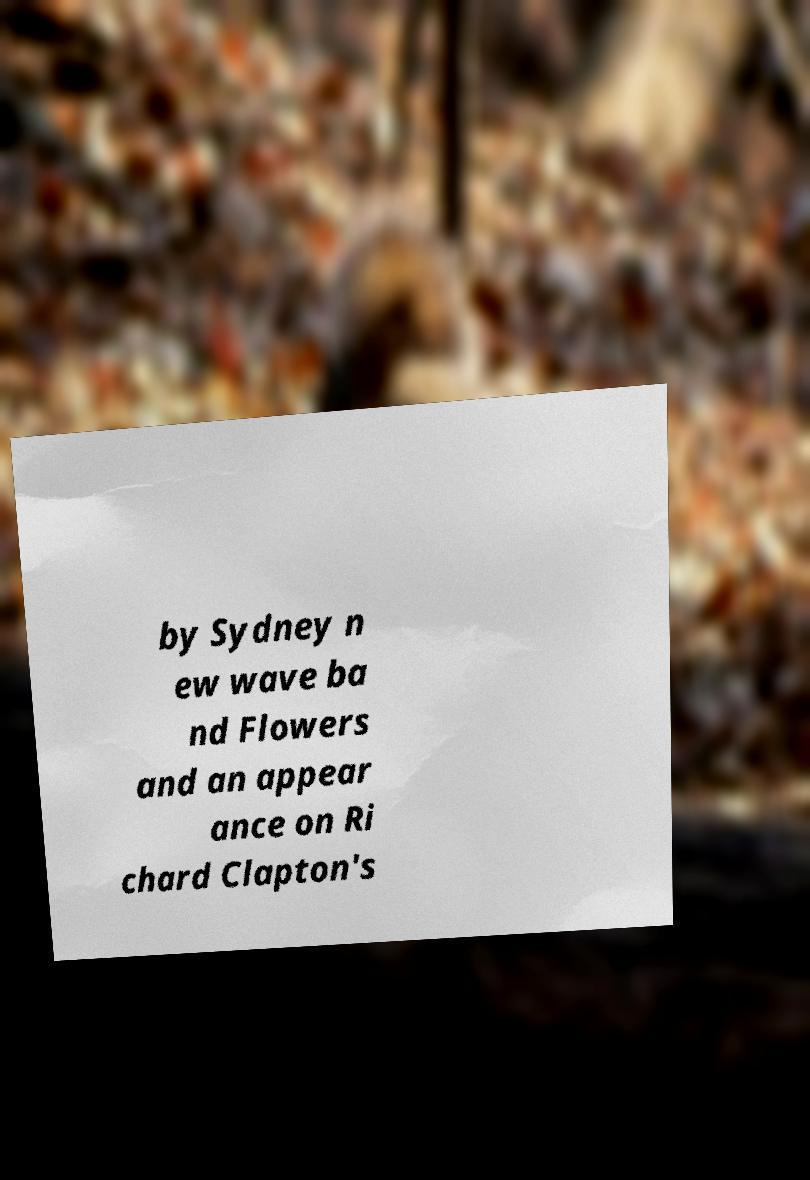Please identify and transcribe the text found in this image. by Sydney n ew wave ba nd Flowers and an appear ance on Ri chard Clapton's 